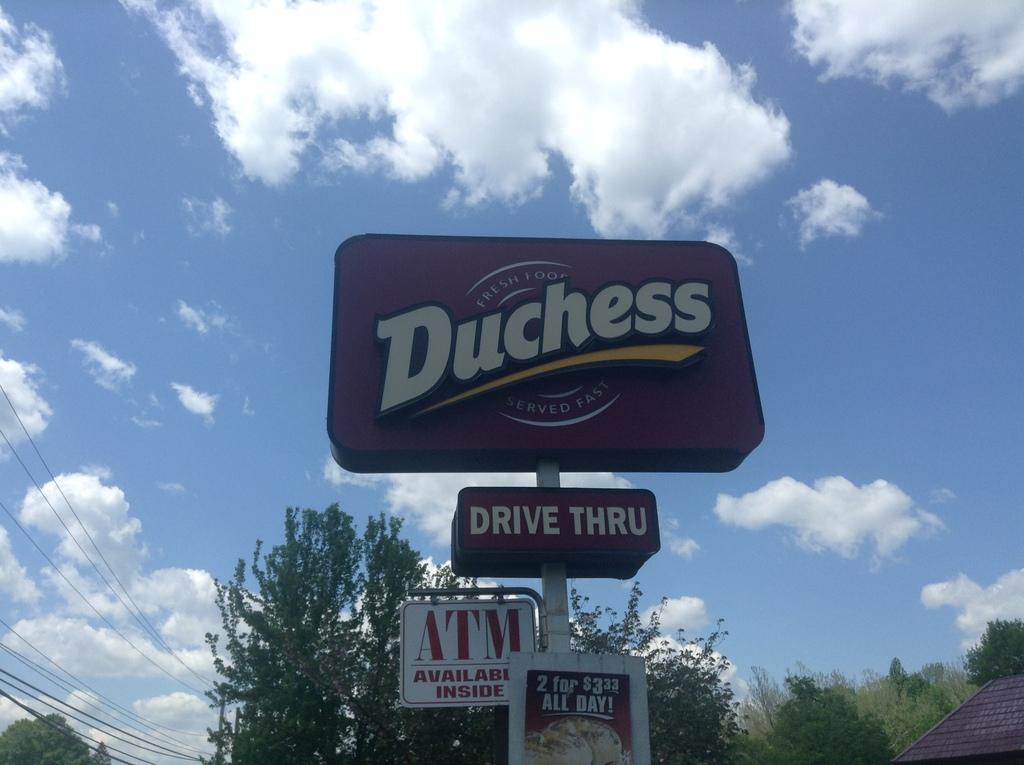<image>
Give a short and clear explanation of the subsequent image. A business sign for Duchess that promises fresh food served fast and a drive thru, ATM, and 2 for 3 dollar food. 